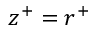Convert formula to latex. <formula><loc_0><loc_0><loc_500><loc_500>z ^ { + } = r ^ { + }</formula> 